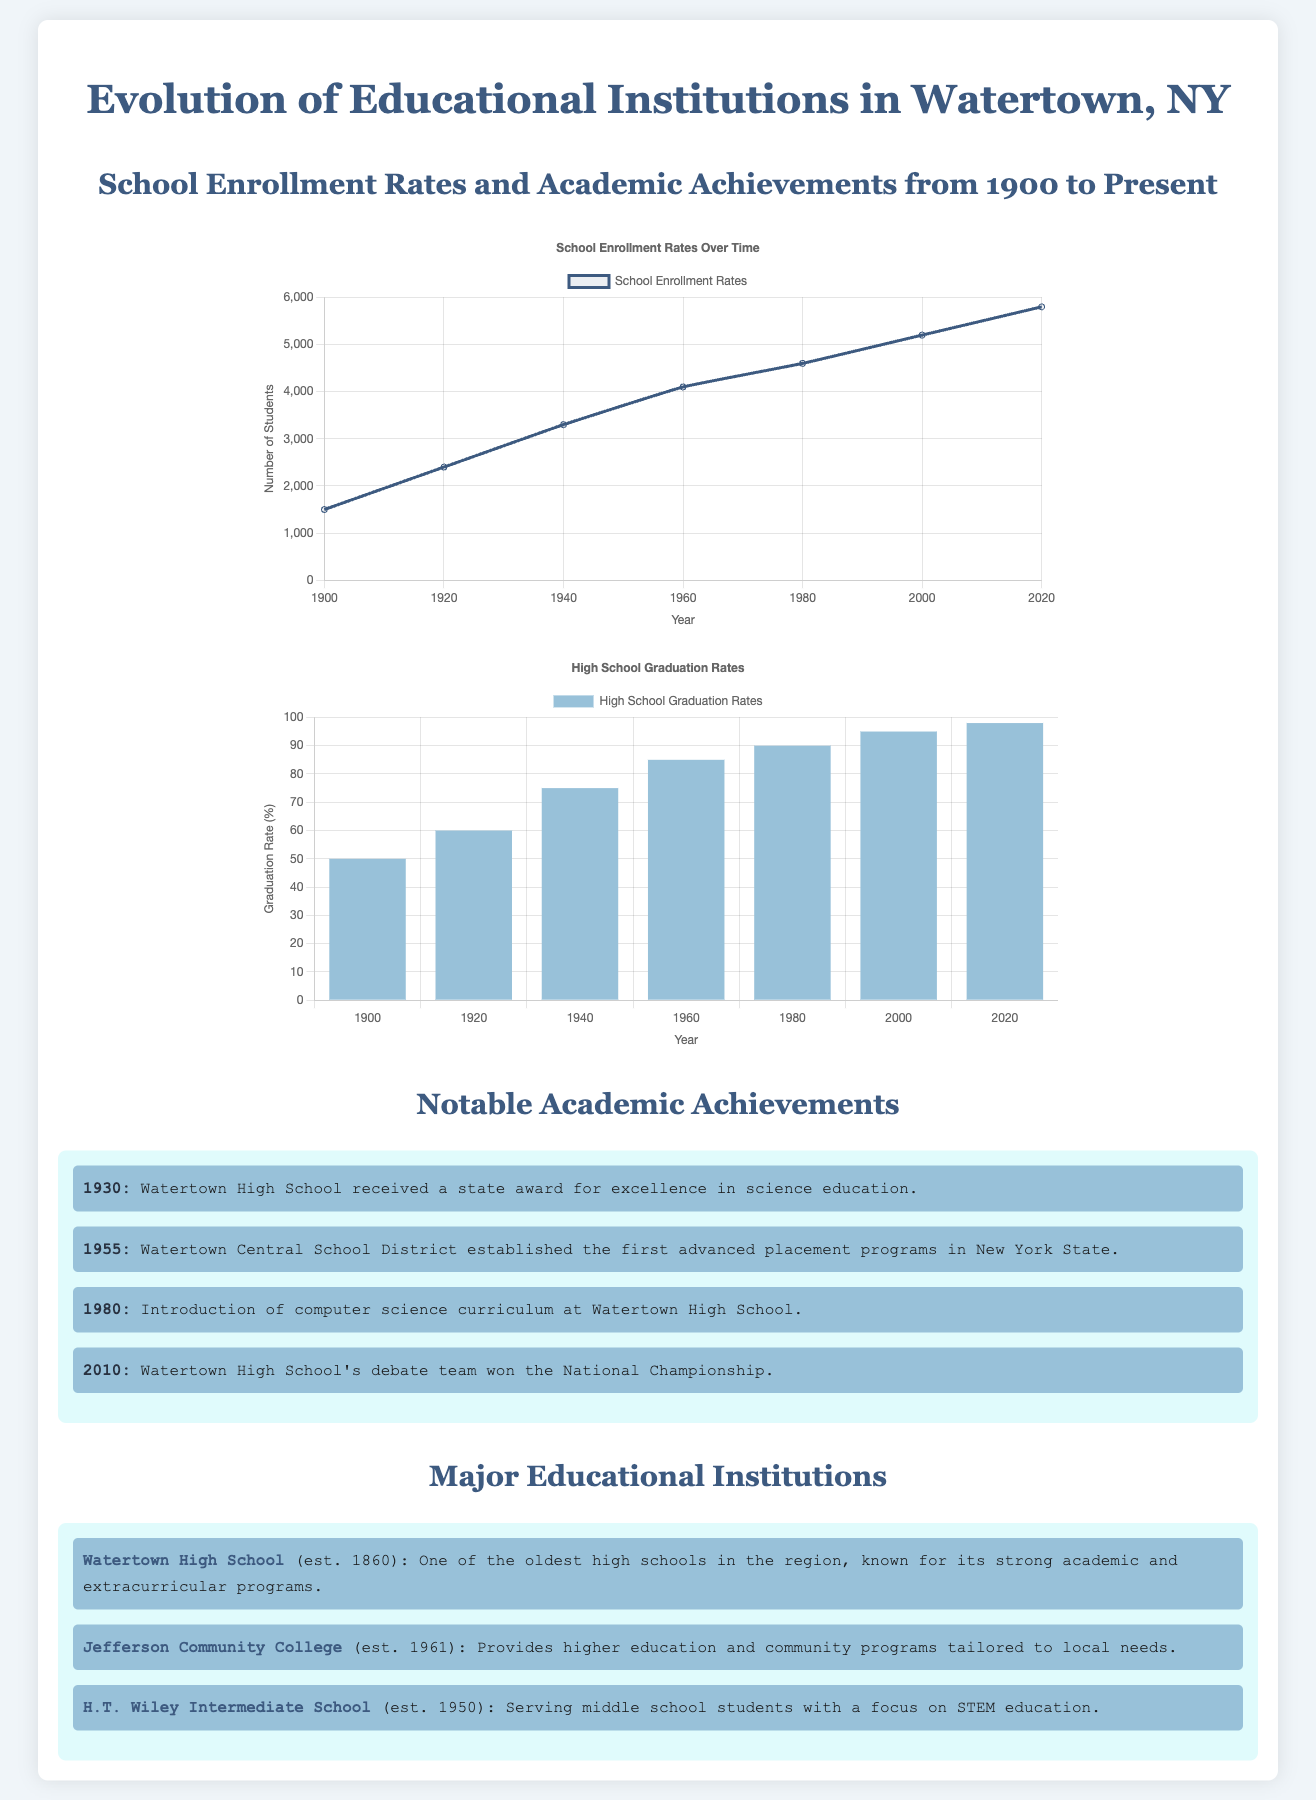What year was Watertown High School established? The document states that Watertown High School was established in 1860.
Answer: 1860 What was the enrollment in 1980? According to the enrollment data, the number of students enrolled in 1980 was 4600.
Answer: 4600 What notable achievement occurred in 2010? The document mentions that Watertown High School's debate team won the National Championship in 2010.
Answer: National Championship What is the highest graduation rate listed? The highest graduation rate mentioned in the document is 98%, which was recorded in 2020.
Answer: 98 Which institution was established in 1961? The document notes that Jefferson Community College was established in 1961.
Answer: Jefferson Community College How many students were enrolled in 1940? Enrollment data shows that in 1940, there were 3300 students enrolled.
Answer: 3300 What is the purpose of Jefferson Community College? The document states that it provides higher education and community programs tailored to local needs.
Answer: Higher education and community programs Which year saw the introduction of computer science curriculum? The introduction of the computer science curriculum at Watertown High School occurred in 1980.
Answer: 1980 What was the graduation rate in 1960? The document indicates that the graduation rate in 1960 was 85 percent.
Answer: 85 